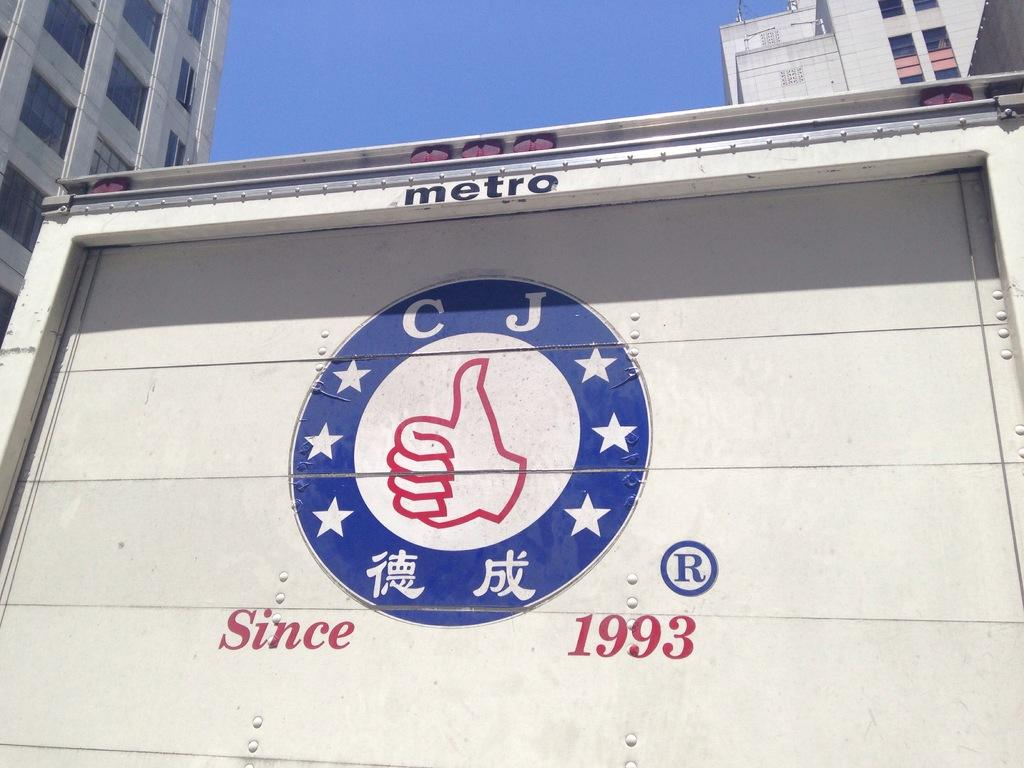What is the main object in the center of the image? There is a board in the center of the image. What can be found on the board? There is text and a logo on the board. What can be seen in the background of the image? There are buildings and the sky visible in the background of the image. How does the father interact with the board in the image? There is no father present in the image, so it is not possible to answer that question. 